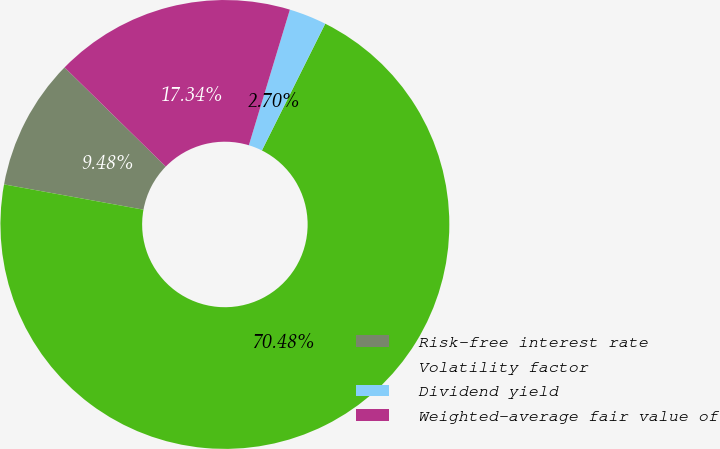<chart> <loc_0><loc_0><loc_500><loc_500><pie_chart><fcel>Risk-free interest rate<fcel>Volatility factor<fcel>Dividend yield<fcel>Weighted-average fair value of<nl><fcel>9.48%<fcel>70.48%<fcel>2.7%<fcel>17.34%<nl></chart> 